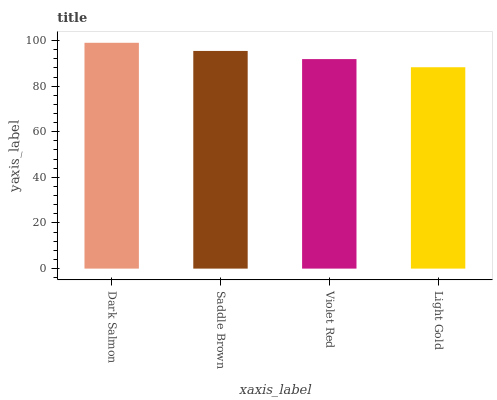Is Light Gold the minimum?
Answer yes or no. Yes. Is Dark Salmon the maximum?
Answer yes or no. Yes. Is Saddle Brown the minimum?
Answer yes or no. No. Is Saddle Brown the maximum?
Answer yes or no. No. Is Dark Salmon greater than Saddle Brown?
Answer yes or no. Yes. Is Saddle Brown less than Dark Salmon?
Answer yes or no. Yes. Is Saddle Brown greater than Dark Salmon?
Answer yes or no. No. Is Dark Salmon less than Saddle Brown?
Answer yes or no. No. Is Saddle Brown the high median?
Answer yes or no. Yes. Is Violet Red the low median?
Answer yes or no. Yes. Is Light Gold the high median?
Answer yes or no. No. Is Saddle Brown the low median?
Answer yes or no. No. 